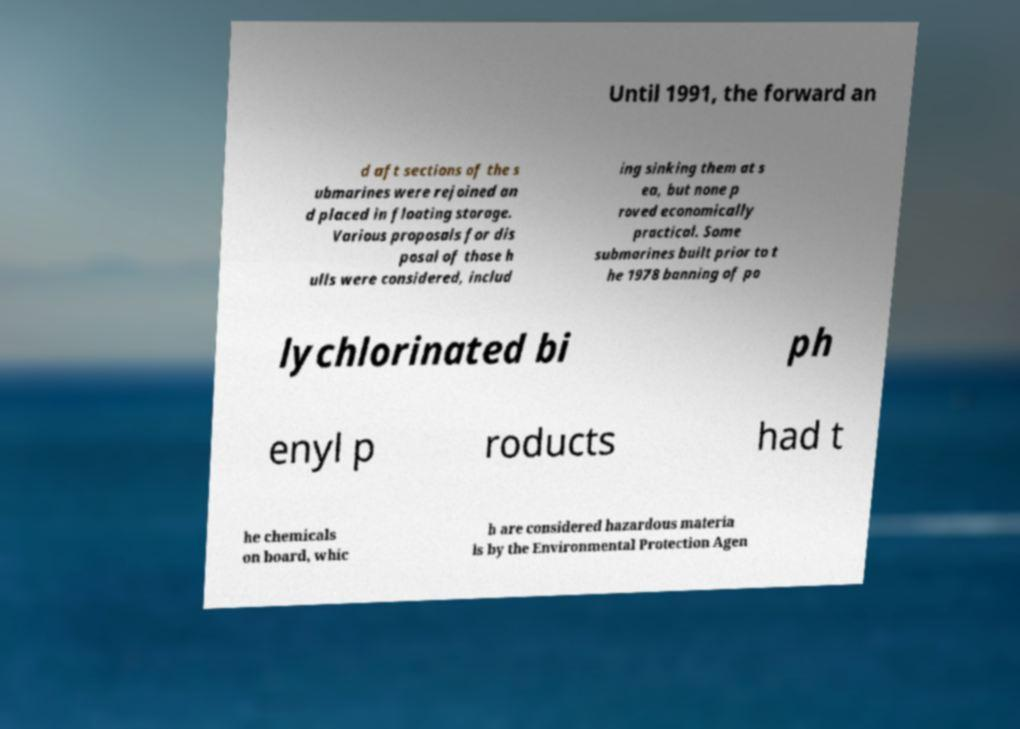Can you accurately transcribe the text from the provided image for me? Until 1991, the forward an d aft sections of the s ubmarines were rejoined an d placed in floating storage. Various proposals for dis posal of those h ulls were considered, includ ing sinking them at s ea, but none p roved economically practical. Some submarines built prior to t he 1978 banning of po lychlorinated bi ph enyl p roducts had t he chemicals on board, whic h are considered hazardous materia ls by the Environmental Protection Agen 